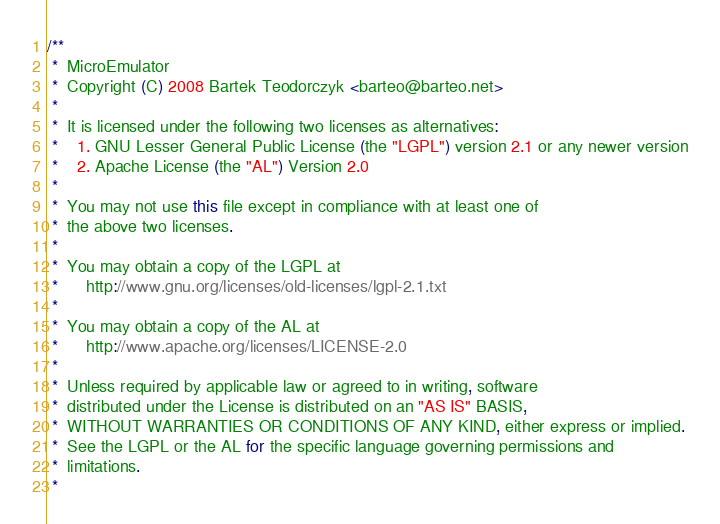Convert code to text. <code><loc_0><loc_0><loc_500><loc_500><_Java_>/**
 *  MicroEmulator
 *  Copyright (C) 2008 Bartek Teodorczyk <barteo@barteo.net>
 *
 *  It is licensed under the following two licenses as alternatives:
 *    1. GNU Lesser General Public License (the "LGPL") version 2.1 or any newer version
 *    2. Apache License (the "AL") Version 2.0
 *
 *  You may not use this file except in compliance with at least one of
 *  the above two licenses.
 *
 *  You may obtain a copy of the LGPL at
 *      http://www.gnu.org/licenses/old-licenses/lgpl-2.1.txt
 *
 *  You may obtain a copy of the AL at
 *      http://www.apache.org/licenses/LICENSE-2.0
 *
 *  Unless required by applicable law or agreed to in writing, software
 *  distributed under the License is distributed on an "AS IS" BASIS,
 *  WITHOUT WARRANTIES OR CONDITIONS OF ANY KIND, either express or implied.
 *  See the LGPL or the AL for the specific language governing permissions and
 *  limitations.
 *</code> 